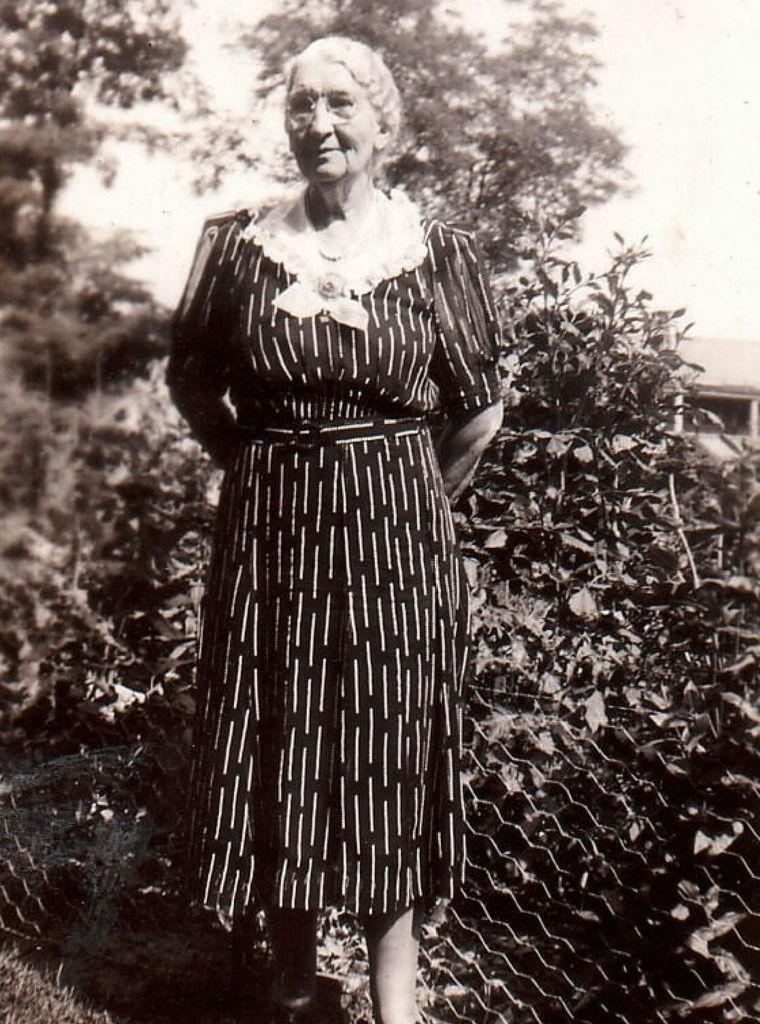What is the main subject of the image? There is a person standing in the image. What type of natural environment is visible in the image? There are trees visible in the image. What is visible in the background of the image? The sky is visible in the image. What type of fencing can be seen in the image? There is net fencing in the image. What type of sugar can be seen growing on the trees in the image? There is no sugar growing on the trees in the image; the trees are not sugar cane. What type of straw is being used by the person in the image? There is no straw visible in the image; the person is not holding or using any straw. 